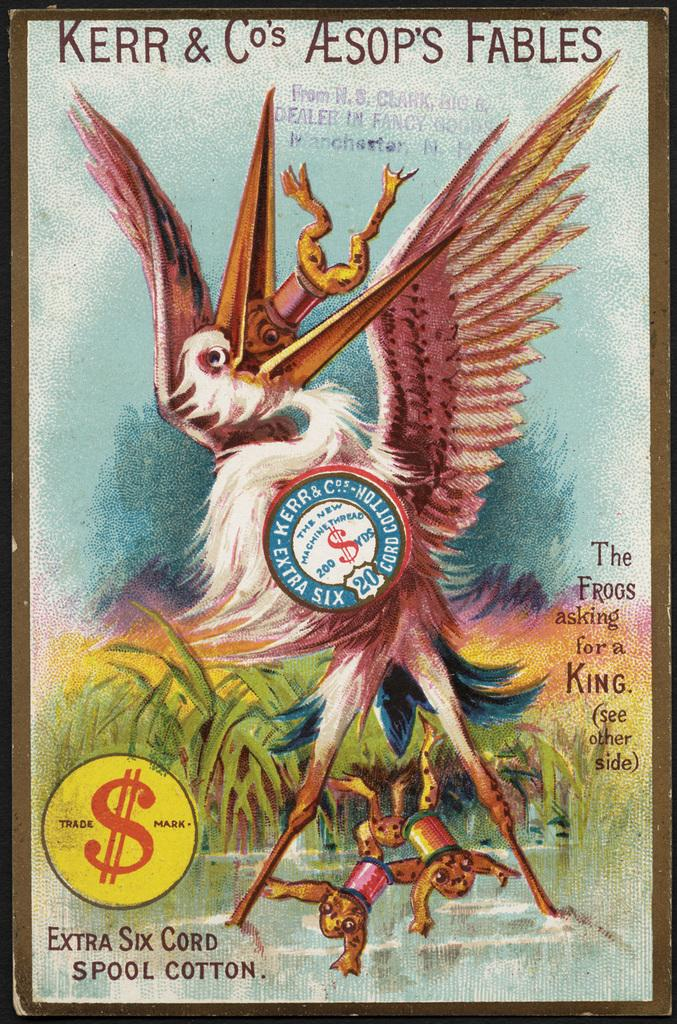<image>
Provide a brief description of the given image. poster for kerr & co's spool cotton that has picture of stork eating frogs with thread spools around them 